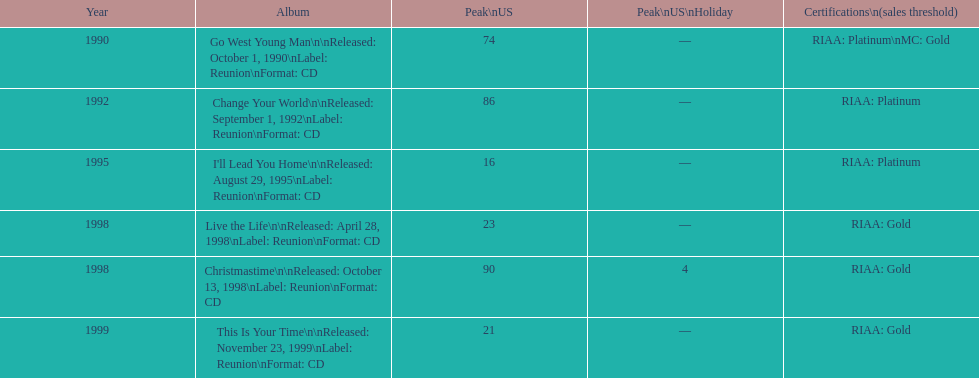Which michael w. smith album achieved the highest position on the us chart? I'll Lead You Home. 